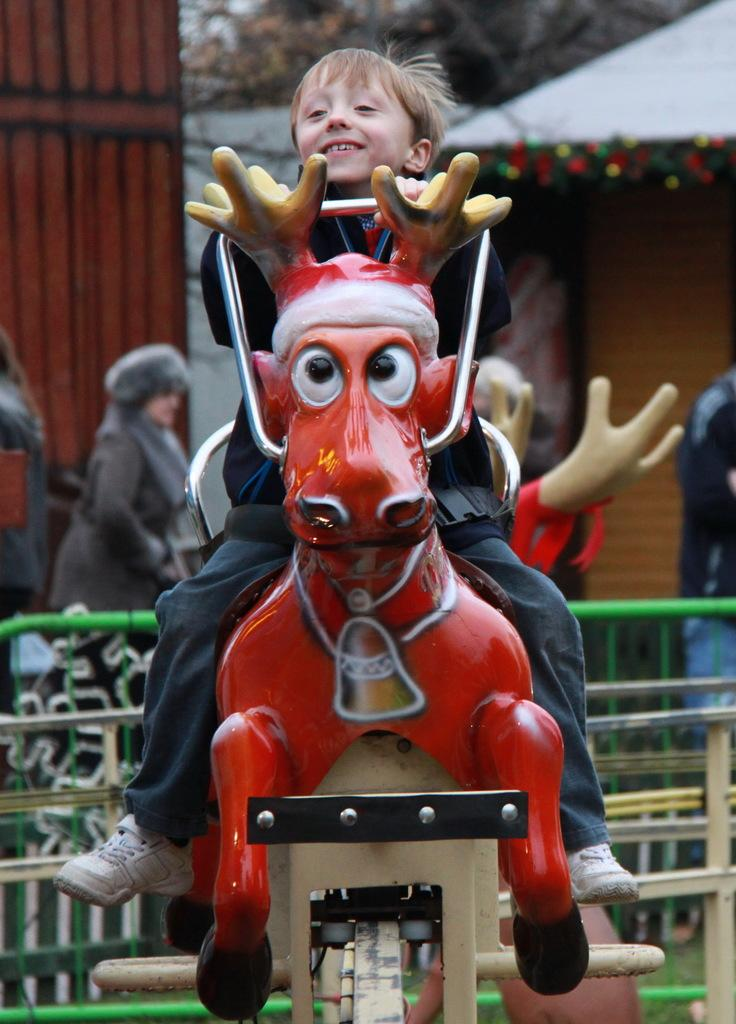What is the boy doing in the image? The boy is sitting on a ride in the image. What can be seen surrounding the ride? There is green color fencing in the image. Are there any other people in the image besides the boy? Yes, people are present in the image. What is visible in the top right corner of the image? There is a shop visible in the top right of the image. What type of vegetation is present behind the shop? Trees are present behind the shop. What type of fear does the boy have while sitting on the ride? There is no indication of fear in the image, and the boy's emotions cannot be determined from the image alone. 